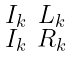Convert formula to latex. <formula><loc_0><loc_0><loc_500><loc_500>\begin{smallmatrix} I _ { k } & L _ { k } \\ I _ { k } & R _ { k } \end{smallmatrix}</formula> 